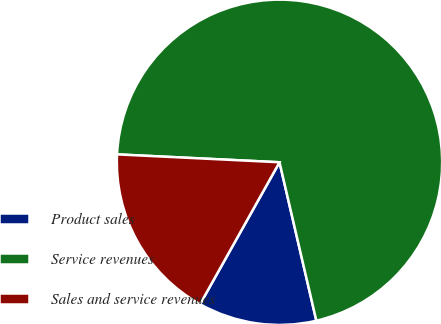<chart> <loc_0><loc_0><loc_500><loc_500><pie_chart><fcel>Product sales<fcel>Service revenues<fcel>Sales and service revenues<nl><fcel>11.76%<fcel>70.59%<fcel>17.65%<nl></chart> 